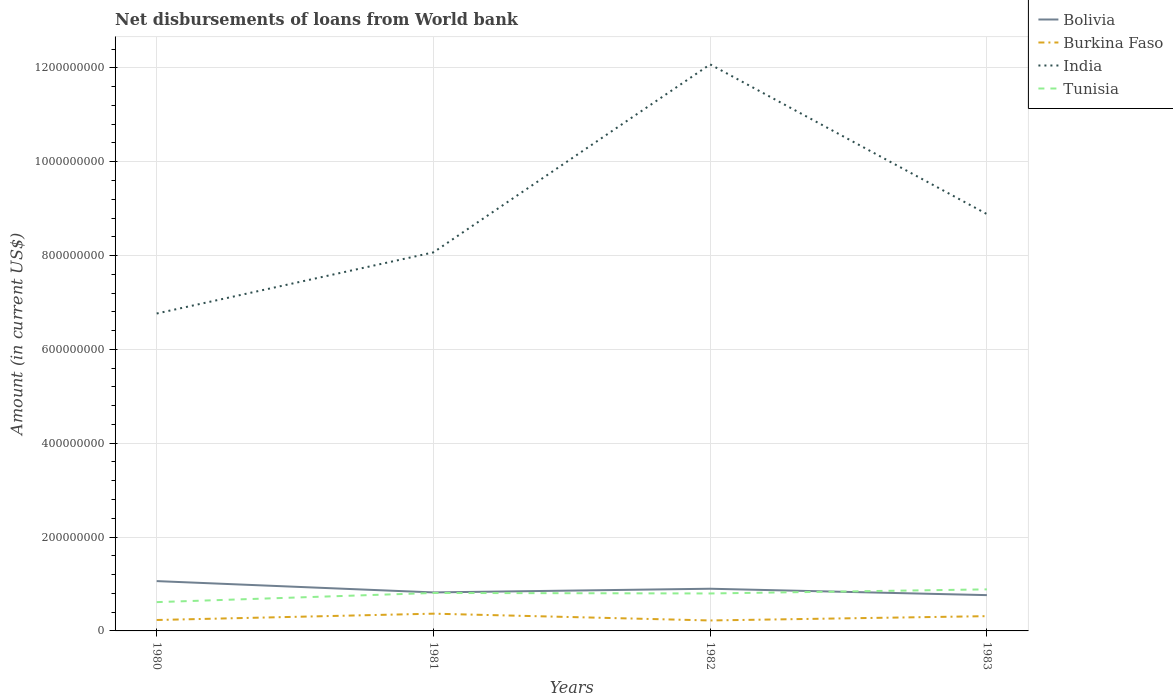Across all years, what is the maximum amount of loan disbursed from World Bank in Burkina Faso?
Give a very brief answer. 2.23e+07. In which year was the amount of loan disbursed from World Bank in India maximum?
Your response must be concise. 1980. What is the total amount of loan disbursed from World Bank in Bolivia in the graph?
Your response must be concise. 5.78e+06. What is the difference between the highest and the second highest amount of loan disbursed from World Bank in Bolivia?
Your answer should be compact. 2.99e+07. What is the difference between the highest and the lowest amount of loan disbursed from World Bank in India?
Give a very brief answer. 1. Is the amount of loan disbursed from World Bank in Burkina Faso strictly greater than the amount of loan disbursed from World Bank in India over the years?
Ensure brevity in your answer.  Yes. How many lines are there?
Your response must be concise. 4. What is the difference between two consecutive major ticks on the Y-axis?
Ensure brevity in your answer.  2.00e+08. Does the graph contain grids?
Your answer should be very brief. Yes. Where does the legend appear in the graph?
Your answer should be very brief. Top right. What is the title of the graph?
Keep it short and to the point. Net disbursements of loans from World bank. Does "Japan" appear as one of the legend labels in the graph?
Offer a terse response. No. What is the Amount (in current US$) in Bolivia in 1980?
Offer a very short reply. 1.06e+08. What is the Amount (in current US$) of Burkina Faso in 1980?
Ensure brevity in your answer.  2.33e+07. What is the Amount (in current US$) in India in 1980?
Your answer should be very brief. 6.76e+08. What is the Amount (in current US$) of Tunisia in 1980?
Your answer should be very brief. 6.14e+07. What is the Amount (in current US$) of Bolivia in 1981?
Offer a very short reply. 8.21e+07. What is the Amount (in current US$) of Burkina Faso in 1981?
Make the answer very short. 3.68e+07. What is the Amount (in current US$) in India in 1981?
Offer a very short reply. 8.07e+08. What is the Amount (in current US$) in Tunisia in 1981?
Make the answer very short. 8.09e+07. What is the Amount (in current US$) of Bolivia in 1982?
Provide a succinct answer. 8.99e+07. What is the Amount (in current US$) of Burkina Faso in 1982?
Offer a terse response. 2.23e+07. What is the Amount (in current US$) in India in 1982?
Give a very brief answer. 1.21e+09. What is the Amount (in current US$) of Tunisia in 1982?
Provide a short and direct response. 7.98e+07. What is the Amount (in current US$) in Bolivia in 1983?
Provide a succinct answer. 7.63e+07. What is the Amount (in current US$) in Burkina Faso in 1983?
Ensure brevity in your answer.  3.15e+07. What is the Amount (in current US$) in India in 1983?
Provide a short and direct response. 8.88e+08. What is the Amount (in current US$) in Tunisia in 1983?
Make the answer very short. 8.86e+07. Across all years, what is the maximum Amount (in current US$) in Bolivia?
Make the answer very short. 1.06e+08. Across all years, what is the maximum Amount (in current US$) in Burkina Faso?
Give a very brief answer. 3.68e+07. Across all years, what is the maximum Amount (in current US$) of India?
Your response must be concise. 1.21e+09. Across all years, what is the maximum Amount (in current US$) in Tunisia?
Your response must be concise. 8.86e+07. Across all years, what is the minimum Amount (in current US$) of Bolivia?
Your answer should be compact. 7.63e+07. Across all years, what is the minimum Amount (in current US$) in Burkina Faso?
Your answer should be compact. 2.23e+07. Across all years, what is the minimum Amount (in current US$) in India?
Make the answer very short. 6.76e+08. Across all years, what is the minimum Amount (in current US$) of Tunisia?
Make the answer very short. 6.14e+07. What is the total Amount (in current US$) of Bolivia in the graph?
Your response must be concise. 3.54e+08. What is the total Amount (in current US$) in Burkina Faso in the graph?
Provide a short and direct response. 1.14e+08. What is the total Amount (in current US$) of India in the graph?
Your answer should be very brief. 3.58e+09. What is the total Amount (in current US$) in Tunisia in the graph?
Provide a succinct answer. 3.11e+08. What is the difference between the Amount (in current US$) in Bolivia in 1980 and that in 1981?
Provide a succinct answer. 2.41e+07. What is the difference between the Amount (in current US$) in Burkina Faso in 1980 and that in 1981?
Make the answer very short. -1.35e+07. What is the difference between the Amount (in current US$) in India in 1980 and that in 1981?
Offer a terse response. -1.30e+08. What is the difference between the Amount (in current US$) of Tunisia in 1980 and that in 1981?
Provide a succinct answer. -1.95e+07. What is the difference between the Amount (in current US$) in Bolivia in 1980 and that in 1982?
Ensure brevity in your answer.  1.63e+07. What is the difference between the Amount (in current US$) in Burkina Faso in 1980 and that in 1982?
Your answer should be very brief. 9.96e+05. What is the difference between the Amount (in current US$) of India in 1980 and that in 1982?
Give a very brief answer. -5.31e+08. What is the difference between the Amount (in current US$) in Tunisia in 1980 and that in 1982?
Offer a terse response. -1.84e+07. What is the difference between the Amount (in current US$) in Bolivia in 1980 and that in 1983?
Your answer should be very brief. 2.99e+07. What is the difference between the Amount (in current US$) of Burkina Faso in 1980 and that in 1983?
Offer a terse response. -8.18e+06. What is the difference between the Amount (in current US$) of India in 1980 and that in 1983?
Give a very brief answer. -2.12e+08. What is the difference between the Amount (in current US$) in Tunisia in 1980 and that in 1983?
Offer a very short reply. -2.72e+07. What is the difference between the Amount (in current US$) of Bolivia in 1981 and that in 1982?
Keep it short and to the point. -7.86e+06. What is the difference between the Amount (in current US$) in Burkina Faso in 1981 and that in 1982?
Make the answer very short. 1.45e+07. What is the difference between the Amount (in current US$) of India in 1981 and that in 1982?
Make the answer very short. -4.01e+08. What is the difference between the Amount (in current US$) of Tunisia in 1981 and that in 1982?
Ensure brevity in your answer.  1.08e+06. What is the difference between the Amount (in current US$) of Bolivia in 1981 and that in 1983?
Give a very brief answer. 5.78e+06. What is the difference between the Amount (in current US$) in Burkina Faso in 1981 and that in 1983?
Keep it short and to the point. 5.28e+06. What is the difference between the Amount (in current US$) in India in 1981 and that in 1983?
Your answer should be compact. -8.16e+07. What is the difference between the Amount (in current US$) in Tunisia in 1981 and that in 1983?
Keep it short and to the point. -7.66e+06. What is the difference between the Amount (in current US$) in Bolivia in 1982 and that in 1983?
Give a very brief answer. 1.36e+07. What is the difference between the Amount (in current US$) in Burkina Faso in 1982 and that in 1983?
Offer a terse response. -9.18e+06. What is the difference between the Amount (in current US$) of India in 1982 and that in 1983?
Your response must be concise. 3.19e+08. What is the difference between the Amount (in current US$) of Tunisia in 1982 and that in 1983?
Make the answer very short. -8.74e+06. What is the difference between the Amount (in current US$) in Bolivia in 1980 and the Amount (in current US$) in Burkina Faso in 1981?
Keep it short and to the point. 6.94e+07. What is the difference between the Amount (in current US$) of Bolivia in 1980 and the Amount (in current US$) of India in 1981?
Your answer should be very brief. -7.01e+08. What is the difference between the Amount (in current US$) in Bolivia in 1980 and the Amount (in current US$) in Tunisia in 1981?
Offer a very short reply. 2.53e+07. What is the difference between the Amount (in current US$) of Burkina Faso in 1980 and the Amount (in current US$) of India in 1981?
Give a very brief answer. -7.83e+08. What is the difference between the Amount (in current US$) in Burkina Faso in 1980 and the Amount (in current US$) in Tunisia in 1981?
Keep it short and to the point. -5.76e+07. What is the difference between the Amount (in current US$) of India in 1980 and the Amount (in current US$) of Tunisia in 1981?
Provide a short and direct response. 5.96e+08. What is the difference between the Amount (in current US$) of Bolivia in 1980 and the Amount (in current US$) of Burkina Faso in 1982?
Your answer should be very brief. 8.39e+07. What is the difference between the Amount (in current US$) in Bolivia in 1980 and the Amount (in current US$) in India in 1982?
Offer a terse response. -1.10e+09. What is the difference between the Amount (in current US$) in Bolivia in 1980 and the Amount (in current US$) in Tunisia in 1982?
Keep it short and to the point. 2.64e+07. What is the difference between the Amount (in current US$) in Burkina Faso in 1980 and the Amount (in current US$) in India in 1982?
Provide a succinct answer. -1.18e+09. What is the difference between the Amount (in current US$) of Burkina Faso in 1980 and the Amount (in current US$) of Tunisia in 1982?
Keep it short and to the point. -5.65e+07. What is the difference between the Amount (in current US$) in India in 1980 and the Amount (in current US$) in Tunisia in 1982?
Offer a very short reply. 5.97e+08. What is the difference between the Amount (in current US$) in Bolivia in 1980 and the Amount (in current US$) in Burkina Faso in 1983?
Keep it short and to the point. 7.47e+07. What is the difference between the Amount (in current US$) in Bolivia in 1980 and the Amount (in current US$) in India in 1983?
Give a very brief answer. -7.82e+08. What is the difference between the Amount (in current US$) in Bolivia in 1980 and the Amount (in current US$) in Tunisia in 1983?
Ensure brevity in your answer.  1.76e+07. What is the difference between the Amount (in current US$) of Burkina Faso in 1980 and the Amount (in current US$) of India in 1983?
Your answer should be compact. -8.65e+08. What is the difference between the Amount (in current US$) in Burkina Faso in 1980 and the Amount (in current US$) in Tunisia in 1983?
Make the answer very short. -6.53e+07. What is the difference between the Amount (in current US$) of India in 1980 and the Amount (in current US$) of Tunisia in 1983?
Your response must be concise. 5.88e+08. What is the difference between the Amount (in current US$) of Bolivia in 1981 and the Amount (in current US$) of Burkina Faso in 1982?
Offer a very short reply. 5.98e+07. What is the difference between the Amount (in current US$) of Bolivia in 1981 and the Amount (in current US$) of India in 1982?
Make the answer very short. -1.13e+09. What is the difference between the Amount (in current US$) in Bolivia in 1981 and the Amount (in current US$) in Tunisia in 1982?
Offer a terse response. 2.24e+06. What is the difference between the Amount (in current US$) of Burkina Faso in 1981 and the Amount (in current US$) of India in 1982?
Your answer should be very brief. -1.17e+09. What is the difference between the Amount (in current US$) in Burkina Faso in 1981 and the Amount (in current US$) in Tunisia in 1982?
Your response must be concise. -4.31e+07. What is the difference between the Amount (in current US$) in India in 1981 and the Amount (in current US$) in Tunisia in 1982?
Provide a short and direct response. 7.27e+08. What is the difference between the Amount (in current US$) in Bolivia in 1981 and the Amount (in current US$) in Burkina Faso in 1983?
Offer a terse response. 5.06e+07. What is the difference between the Amount (in current US$) in Bolivia in 1981 and the Amount (in current US$) in India in 1983?
Your response must be concise. -8.06e+08. What is the difference between the Amount (in current US$) of Bolivia in 1981 and the Amount (in current US$) of Tunisia in 1983?
Provide a succinct answer. -6.50e+06. What is the difference between the Amount (in current US$) in Burkina Faso in 1981 and the Amount (in current US$) in India in 1983?
Your answer should be very brief. -8.52e+08. What is the difference between the Amount (in current US$) of Burkina Faso in 1981 and the Amount (in current US$) of Tunisia in 1983?
Your answer should be very brief. -5.18e+07. What is the difference between the Amount (in current US$) of India in 1981 and the Amount (in current US$) of Tunisia in 1983?
Give a very brief answer. 7.18e+08. What is the difference between the Amount (in current US$) in Bolivia in 1982 and the Amount (in current US$) in Burkina Faso in 1983?
Provide a succinct answer. 5.84e+07. What is the difference between the Amount (in current US$) of Bolivia in 1982 and the Amount (in current US$) of India in 1983?
Provide a short and direct response. -7.98e+08. What is the difference between the Amount (in current US$) of Bolivia in 1982 and the Amount (in current US$) of Tunisia in 1983?
Ensure brevity in your answer.  1.36e+06. What is the difference between the Amount (in current US$) of Burkina Faso in 1982 and the Amount (in current US$) of India in 1983?
Your answer should be compact. -8.66e+08. What is the difference between the Amount (in current US$) in Burkina Faso in 1982 and the Amount (in current US$) in Tunisia in 1983?
Provide a succinct answer. -6.63e+07. What is the difference between the Amount (in current US$) of India in 1982 and the Amount (in current US$) of Tunisia in 1983?
Provide a short and direct response. 1.12e+09. What is the average Amount (in current US$) in Bolivia per year?
Give a very brief answer. 8.86e+07. What is the average Amount (in current US$) of Burkina Faso per year?
Your response must be concise. 2.85e+07. What is the average Amount (in current US$) of India per year?
Offer a terse response. 8.95e+08. What is the average Amount (in current US$) in Tunisia per year?
Your answer should be very brief. 7.77e+07. In the year 1980, what is the difference between the Amount (in current US$) of Bolivia and Amount (in current US$) of Burkina Faso?
Your answer should be very brief. 8.29e+07. In the year 1980, what is the difference between the Amount (in current US$) of Bolivia and Amount (in current US$) of India?
Ensure brevity in your answer.  -5.70e+08. In the year 1980, what is the difference between the Amount (in current US$) in Bolivia and Amount (in current US$) in Tunisia?
Make the answer very short. 4.48e+07. In the year 1980, what is the difference between the Amount (in current US$) of Burkina Faso and Amount (in current US$) of India?
Ensure brevity in your answer.  -6.53e+08. In the year 1980, what is the difference between the Amount (in current US$) of Burkina Faso and Amount (in current US$) of Tunisia?
Make the answer very short. -3.81e+07. In the year 1980, what is the difference between the Amount (in current US$) in India and Amount (in current US$) in Tunisia?
Your answer should be compact. 6.15e+08. In the year 1981, what is the difference between the Amount (in current US$) in Bolivia and Amount (in current US$) in Burkina Faso?
Give a very brief answer. 4.53e+07. In the year 1981, what is the difference between the Amount (in current US$) of Bolivia and Amount (in current US$) of India?
Provide a short and direct response. -7.25e+08. In the year 1981, what is the difference between the Amount (in current US$) in Bolivia and Amount (in current US$) in Tunisia?
Offer a very short reply. 1.16e+06. In the year 1981, what is the difference between the Amount (in current US$) in Burkina Faso and Amount (in current US$) in India?
Keep it short and to the point. -7.70e+08. In the year 1981, what is the difference between the Amount (in current US$) of Burkina Faso and Amount (in current US$) of Tunisia?
Make the answer very short. -4.41e+07. In the year 1981, what is the difference between the Amount (in current US$) of India and Amount (in current US$) of Tunisia?
Your response must be concise. 7.26e+08. In the year 1982, what is the difference between the Amount (in current US$) of Bolivia and Amount (in current US$) of Burkina Faso?
Offer a terse response. 6.76e+07. In the year 1982, what is the difference between the Amount (in current US$) in Bolivia and Amount (in current US$) in India?
Keep it short and to the point. -1.12e+09. In the year 1982, what is the difference between the Amount (in current US$) of Bolivia and Amount (in current US$) of Tunisia?
Offer a very short reply. 1.01e+07. In the year 1982, what is the difference between the Amount (in current US$) of Burkina Faso and Amount (in current US$) of India?
Your answer should be very brief. -1.19e+09. In the year 1982, what is the difference between the Amount (in current US$) in Burkina Faso and Amount (in current US$) in Tunisia?
Your answer should be compact. -5.75e+07. In the year 1982, what is the difference between the Amount (in current US$) of India and Amount (in current US$) of Tunisia?
Keep it short and to the point. 1.13e+09. In the year 1983, what is the difference between the Amount (in current US$) in Bolivia and Amount (in current US$) in Burkina Faso?
Provide a short and direct response. 4.48e+07. In the year 1983, what is the difference between the Amount (in current US$) in Bolivia and Amount (in current US$) in India?
Give a very brief answer. -8.12e+08. In the year 1983, what is the difference between the Amount (in current US$) of Bolivia and Amount (in current US$) of Tunisia?
Your response must be concise. -1.23e+07. In the year 1983, what is the difference between the Amount (in current US$) in Burkina Faso and Amount (in current US$) in India?
Offer a very short reply. -8.57e+08. In the year 1983, what is the difference between the Amount (in current US$) of Burkina Faso and Amount (in current US$) of Tunisia?
Offer a very short reply. -5.71e+07. In the year 1983, what is the difference between the Amount (in current US$) in India and Amount (in current US$) in Tunisia?
Make the answer very short. 8.00e+08. What is the ratio of the Amount (in current US$) of Bolivia in 1980 to that in 1981?
Offer a very short reply. 1.29. What is the ratio of the Amount (in current US$) in Burkina Faso in 1980 to that in 1981?
Offer a very short reply. 0.63. What is the ratio of the Amount (in current US$) in India in 1980 to that in 1981?
Ensure brevity in your answer.  0.84. What is the ratio of the Amount (in current US$) of Tunisia in 1980 to that in 1981?
Your response must be concise. 0.76. What is the ratio of the Amount (in current US$) of Bolivia in 1980 to that in 1982?
Keep it short and to the point. 1.18. What is the ratio of the Amount (in current US$) of Burkina Faso in 1980 to that in 1982?
Keep it short and to the point. 1.04. What is the ratio of the Amount (in current US$) of India in 1980 to that in 1982?
Give a very brief answer. 0.56. What is the ratio of the Amount (in current US$) of Tunisia in 1980 to that in 1982?
Offer a terse response. 0.77. What is the ratio of the Amount (in current US$) of Bolivia in 1980 to that in 1983?
Your answer should be very brief. 1.39. What is the ratio of the Amount (in current US$) of Burkina Faso in 1980 to that in 1983?
Your answer should be very brief. 0.74. What is the ratio of the Amount (in current US$) in India in 1980 to that in 1983?
Give a very brief answer. 0.76. What is the ratio of the Amount (in current US$) in Tunisia in 1980 to that in 1983?
Your answer should be very brief. 0.69. What is the ratio of the Amount (in current US$) of Bolivia in 1981 to that in 1982?
Ensure brevity in your answer.  0.91. What is the ratio of the Amount (in current US$) in Burkina Faso in 1981 to that in 1982?
Make the answer very short. 1.65. What is the ratio of the Amount (in current US$) in India in 1981 to that in 1982?
Your answer should be compact. 0.67. What is the ratio of the Amount (in current US$) of Tunisia in 1981 to that in 1982?
Provide a short and direct response. 1.01. What is the ratio of the Amount (in current US$) of Bolivia in 1981 to that in 1983?
Keep it short and to the point. 1.08. What is the ratio of the Amount (in current US$) of Burkina Faso in 1981 to that in 1983?
Offer a very short reply. 1.17. What is the ratio of the Amount (in current US$) in India in 1981 to that in 1983?
Provide a short and direct response. 0.91. What is the ratio of the Amount (in current US$) in Tunisia in 1981 to that in 1983?
Your answer should be compact. 0.91. What is the ratio of the Amount (in current US$) of Bolivia in 1982 to that in 1983?
Give a very brief answer. 1.18. What is the ratio of the Amount (in current US$) in Burkina Faso in 1982 to that in 1983?
Give a very brief answer. 0.71. What is the ratio of the Amount (in current US$) of India in 1982 to that in 1983?
Offer a terse response. 1.36. What is the ratio of the Amount (in current US$) of Tunisia in 1982 to that in 1983?
Offer a very short reply. 0.9. What is the difference between the highest and the second highest Amount (in current US$) of Bolivia?
Give a very brief answer. 1.63e+07. What is the difference between the highest and the second highest Amount (in current US$) of Burkina Faso?
Offer a terse response. 5.28e+06. What is the difference between the highest and the second highest Amount (in current US$) of India?
Provide a succinct answer. 3.19e+08. What is the difference between the highest and the second highest Amount (in current US$) in Tunisia?
Make the answer very short. 7.66e+06. What is the difference between the highest and the lowest Amount (in current US$) in Bolivia?
Provide a short and direct response. 2.99e+07. What is the difference between the highest and the lowest Amount (in current US$) of Burkina Faso?
Keep it short and to the point. 1.45e+07. What is the difference between the highest and the lowest Amount (in current US$) of India?
Your answer should be very brief. 5.31e+08. What is the difference between the highest and the lowest Amount (in current US$) of Tunisia?
Your answer should be very brief. 2.72e+07. 